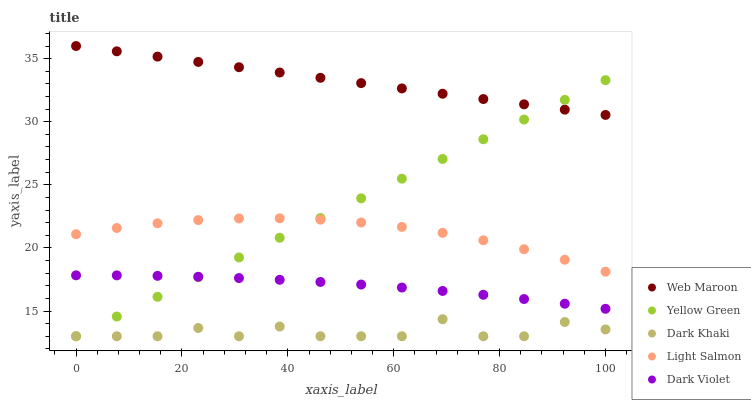Does Dark Khaki have the minimum area under the curve?
Answer yes or no. Yes. Does Web Maroon have the maximum area under the curve?
Answer yes or no. Yes. Does Light Salmon have the minimum area under the curve?
Answer yes or no. No. Does Light Salmon have the maximum area under the curve?
Answer yes or no. No. Is Yellow Green the smoothest?
Answer yes or no. Yes. Is Dark Khaki the roughest?
Answer yes or no. Yes. Is Light Salmon the smoothest?
Answer yes or no. No. Is Light Salmon the roughest?
Answer yes or no. No. Does Dark Khaki have the lowest value?
Answer yes or no. Yes. Does Light Salmon have the lowest value?
Answer yes or no. No. Does Web Maroon have the highest value?
Answer yes or no. Yes. Does Light Salmon have the highest value?
Answer yes or no. No. Is Dark Khaki less than Dark Violet?
Answer yes or no. Yes. Is Web Maroon greater than Dark Khaki?
Answer yes or no. Yes. Does Dark Violet intersect Yellow Green?
Answer yes or no. Yes. Is Dark Violet less than Yellow Green?
Answer yes or no. No. Is Dark Violet greater than Yellow Green?
Answer yes or no. No. Does Dark Khaki intersect Dark Violet?
Answer yes or no. No. 